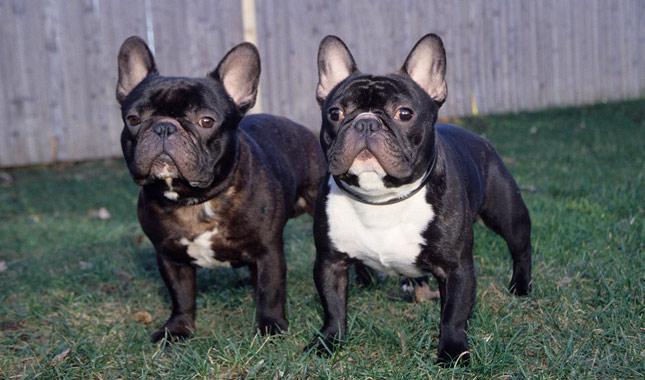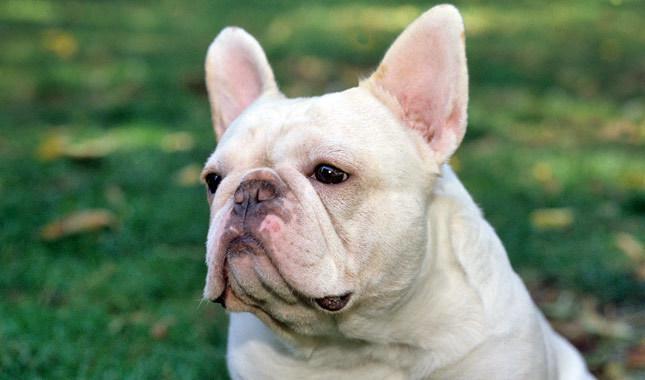The first image is the image on the left, the second image is the image on the right. Examine the images to the left and right. Is the description "There are two french bulldogs, and zero english bulldogs." accurate? Answer yes or no. No. The first image is the image on the left, the second image is the image on the right. Considering the images on both sides, is "There is at least one dog standing on grass-covered ground." valid? Answer yes or no. Yes. 